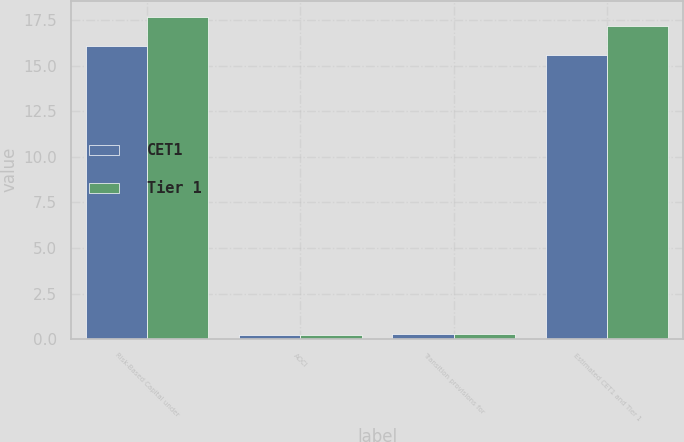Convert chart. <chart><loc_0><loc_0><loc_500><loc_500><stacked_bar_chart><ecel><fcel>Risk-Based Capital under<fcel>AOCI<fcel>Transition provisions for<fcel>Estimated CET1 and Tier 1<nl><fcel>CET1<fcel>16.1<fcel>0.2<fcel>0.3<fcel>15.6<nl><fcel>Tier 1<fcel>17.7<fcel>0.2<fcel>0.3<fcel>17.2<nl></chart> 